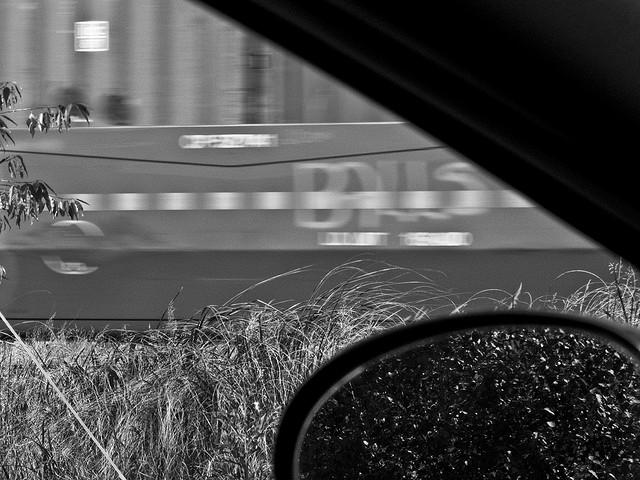Is there texture in the scene?
Concise answer only. Yes. Is there a train in the picture?
Answer briefly. Yes. Is there a wheel on the ground?
Concise answer only. No. 